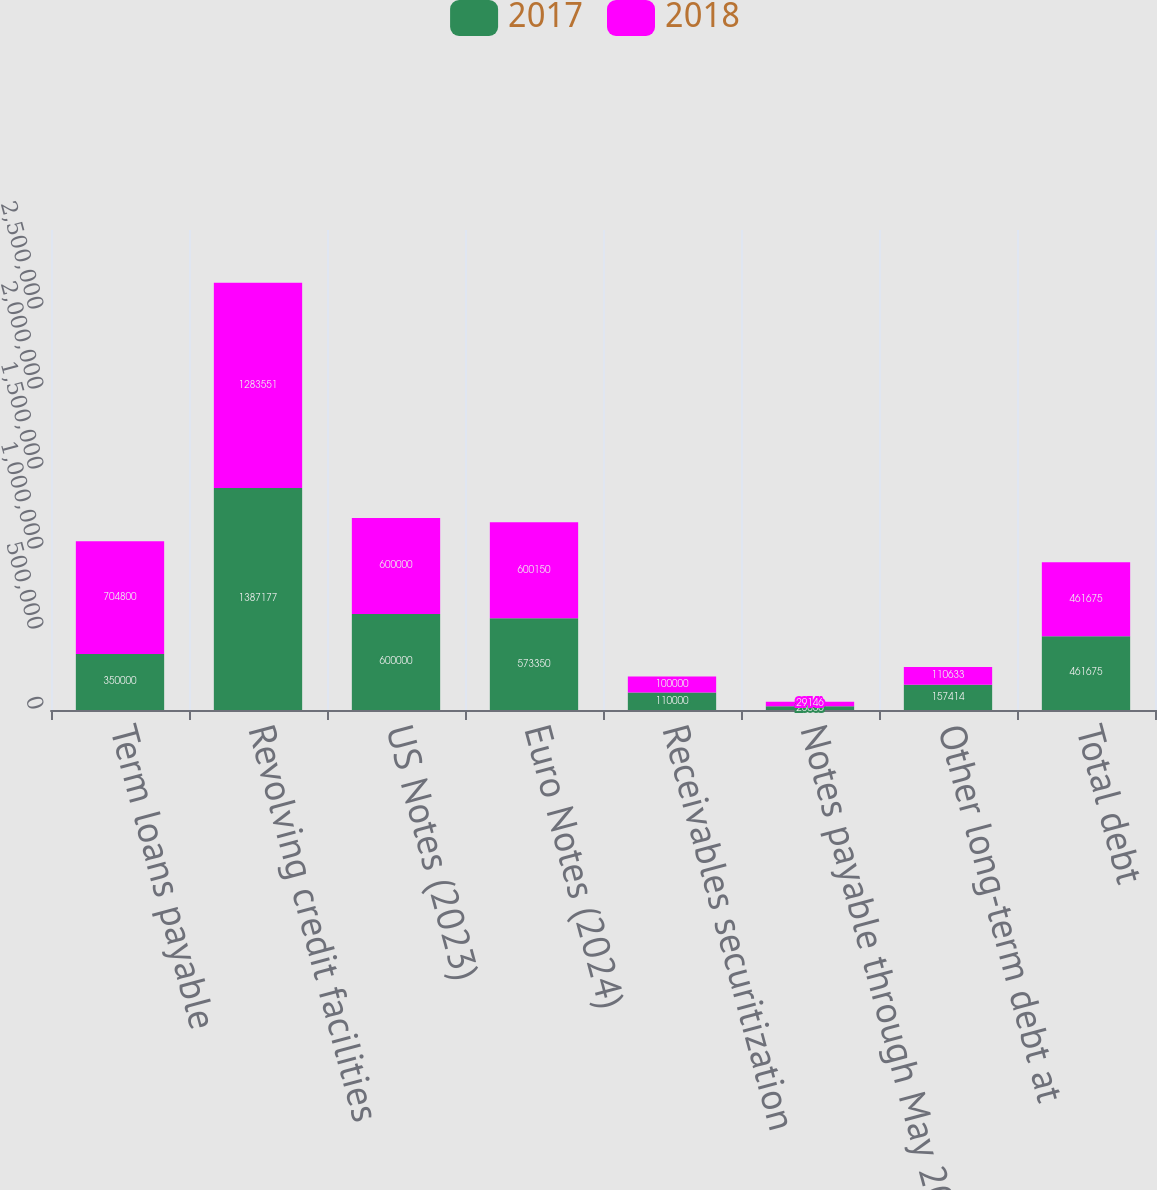<chart> <loc_0><loc_0><loc_500><loc_500><stacked_bar_chart><ecel><fcel>Term loans payable<fcel>Revolving credit facilities<fcel>US Notes (2023)<fcel>Euro Notes (2024)<fcel>Receivables securitization<fcel>Notes payable through May 2027<fcel>Other long-term debt at<fcel>Total debt<nl><fcel>2017<fcel>350000<fcel>1.38718e+06<fcel>600000<fcel>573350<fcel>110000<fcel>23056<fcel>157414<fcel>461675<nl><fcel>2018<fcel>704800<fcel>1.28355e+06<fcel>600000<fcel>600150<fcel>100000<fcel>29146<fcel>110633<fcel>461675<nl></chart> 